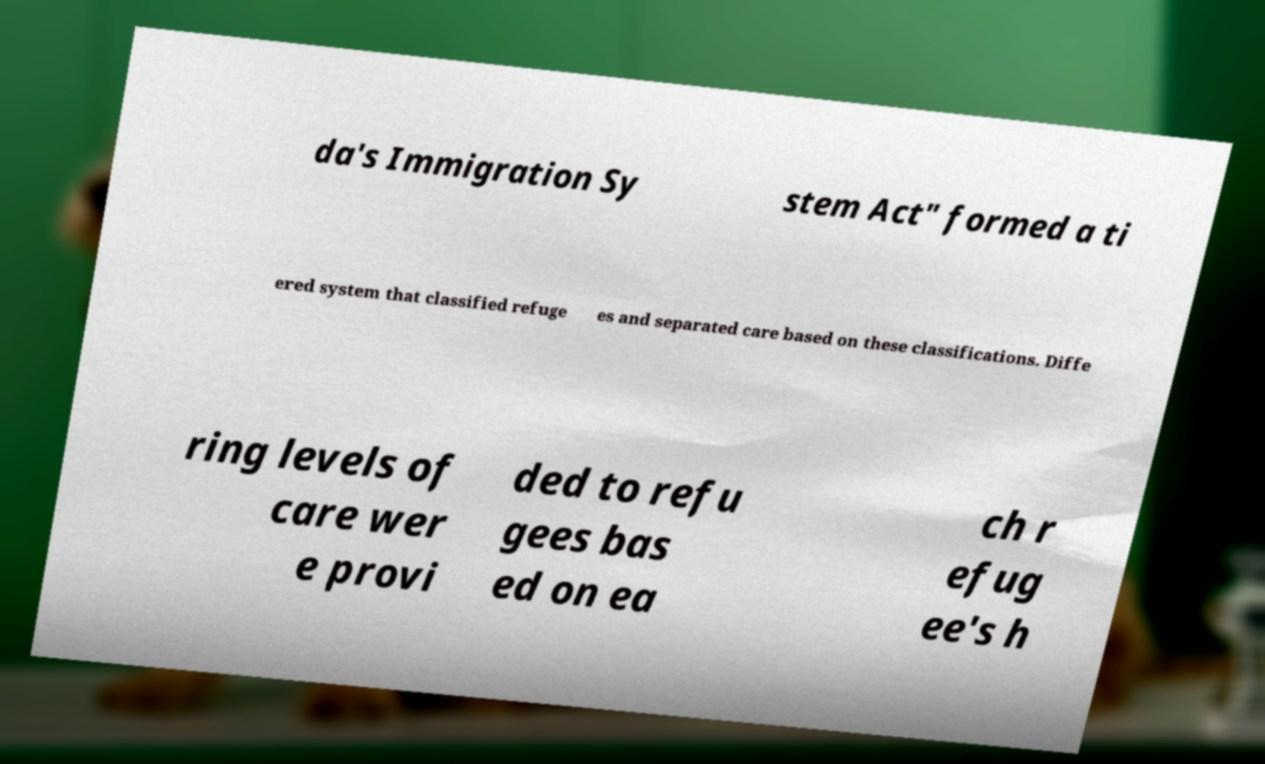Can you read and provide the text displayed in the image?This photo seems to have some interesting text. Can you extract and type it out for me? da's Immigration Sy stem Act" formed a ti ered system that classified refuge es and separated care based on these classifications. Diffe ring levels of care wer e provi ded to refu gees bas ed on ea ch r efug ee's h 